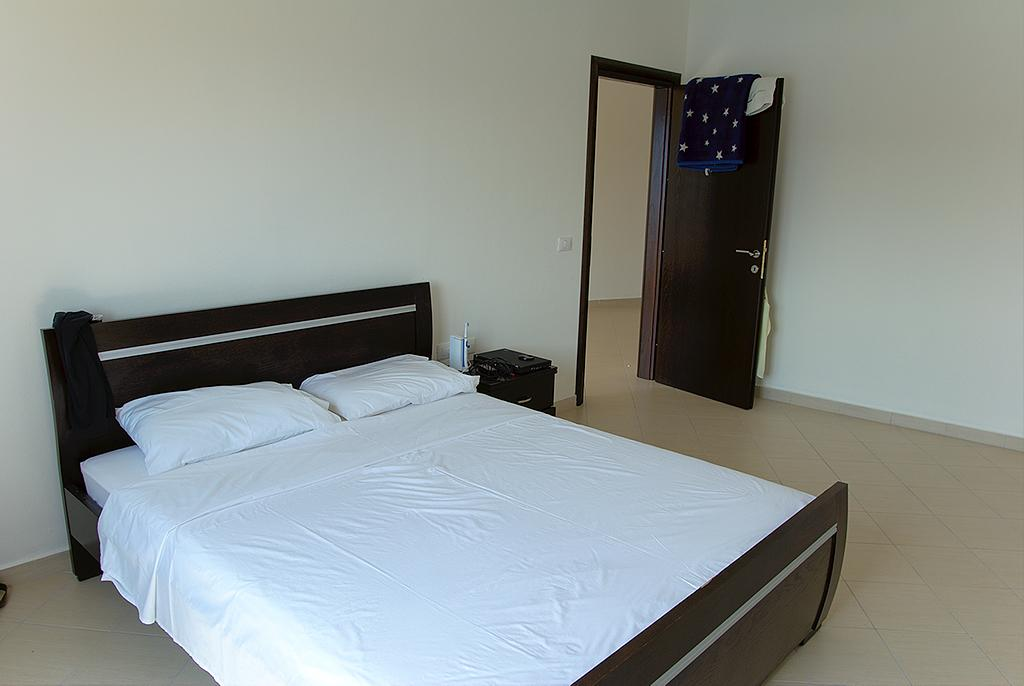What piece of furniture is present in the image? There is a bed in the image. What color are the bed sheets? The bed sheets are white. How many pillows are on the bed? There are 2 pillows on the bed. What type of flooring is visible in the image? The floor has tiles. What object can be seen in addition to the bed? There is a ball in the image. What type of chicken is sitting on the bed in the image? There is no chicken present in the image. 